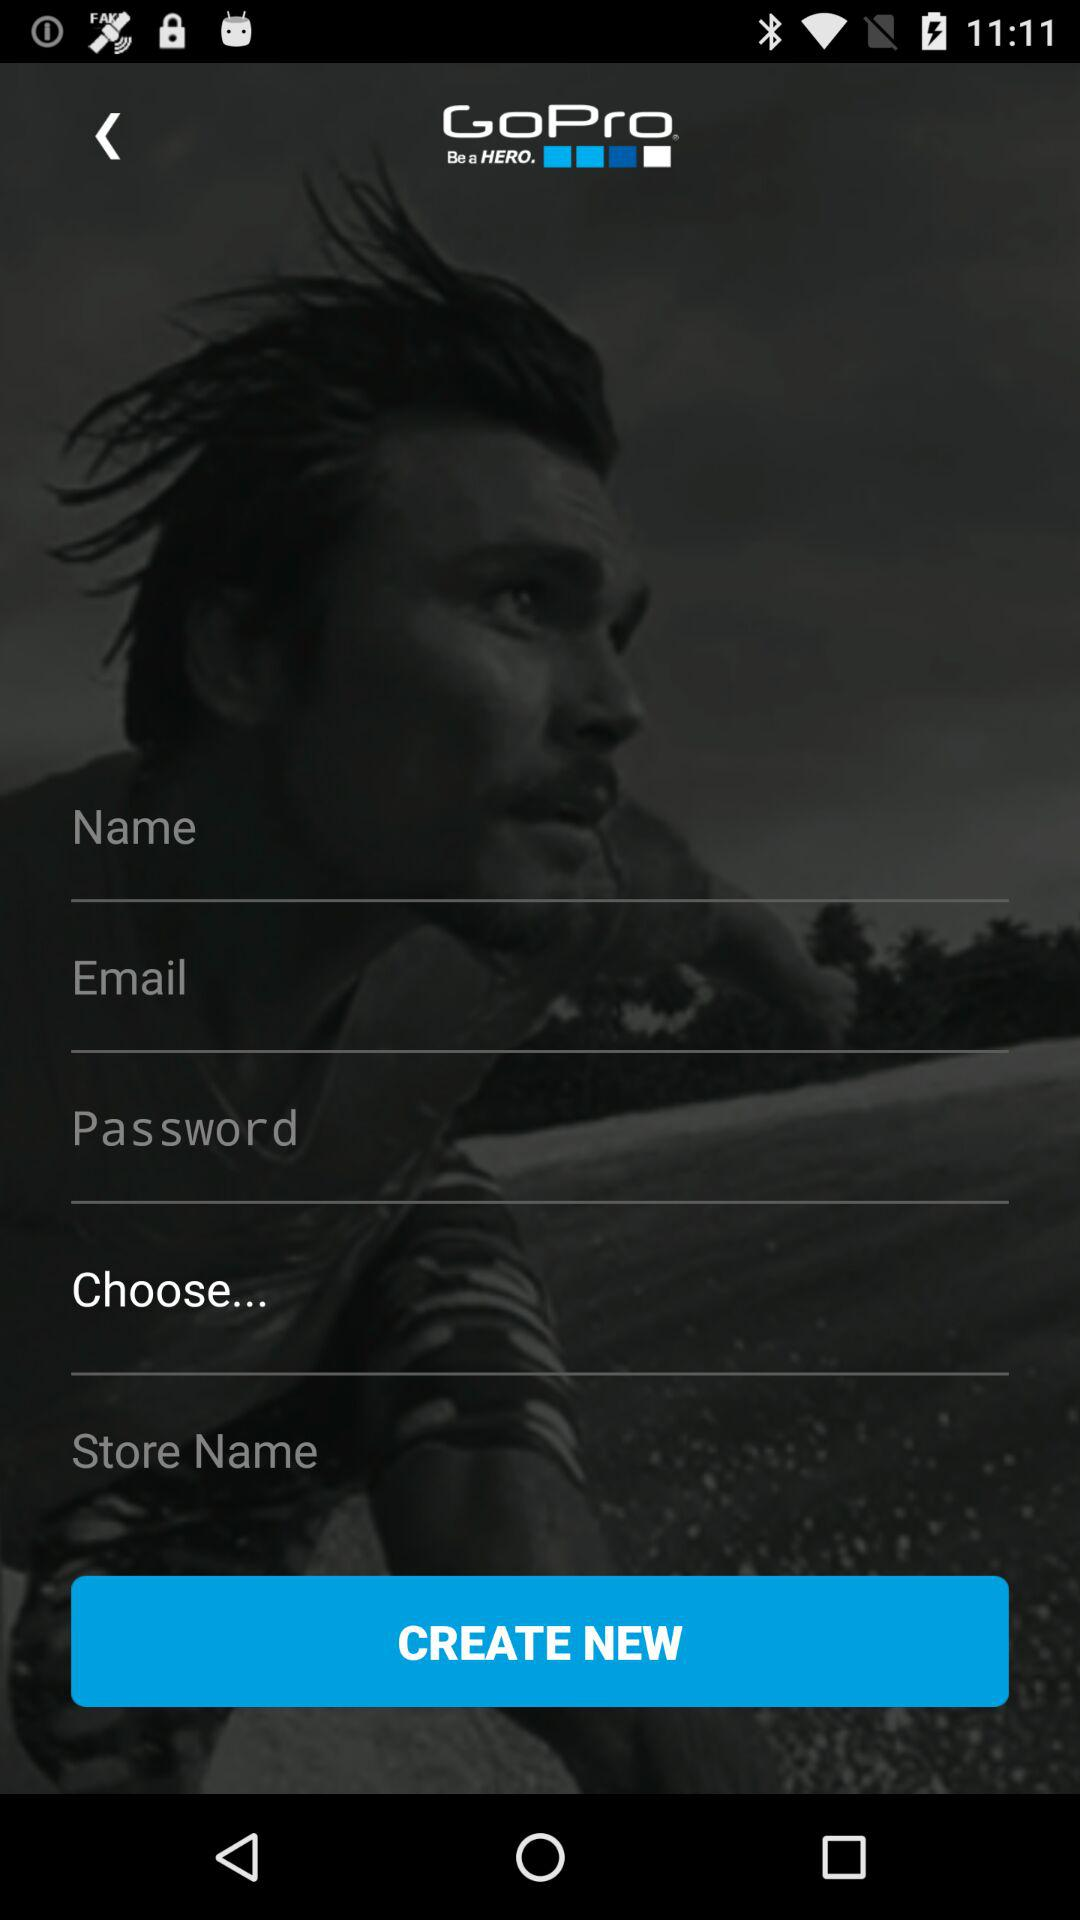What is the name of the application? The name of the application is "GoPro". 